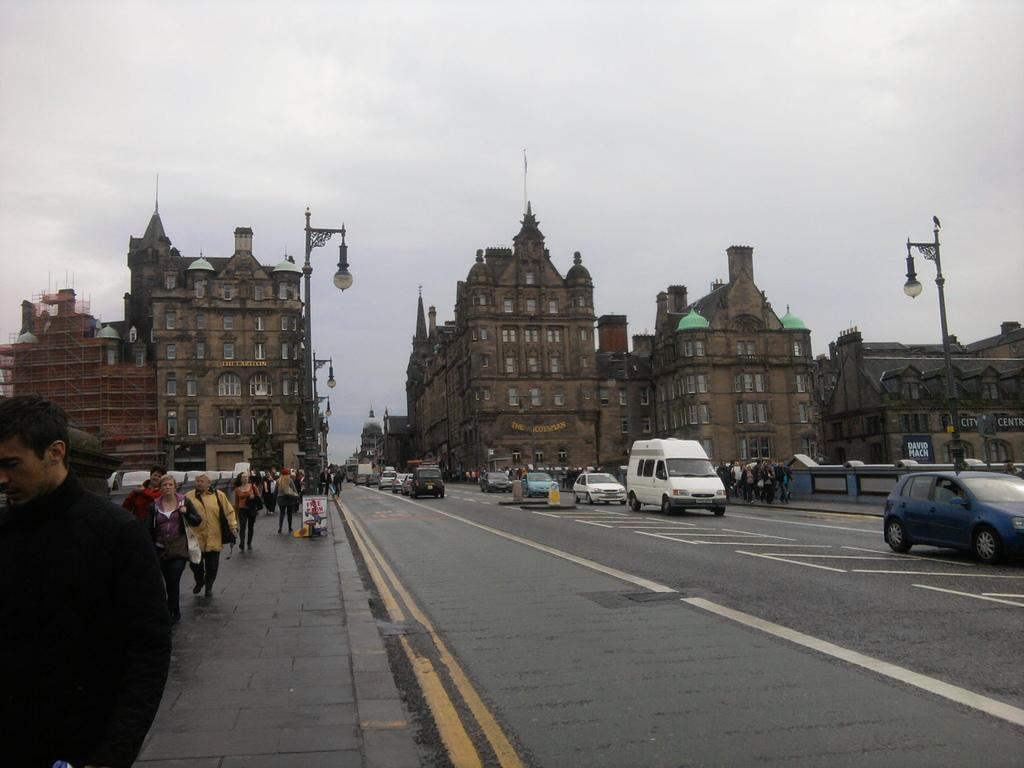What are the people in the image doing? The people in the image are walking. What else can be seen on the road in the image? There are vehicles on the road in the image. What type of infrastructure is present in the image? There are lights on poles in the image. What can be seen in the distance in the image? There are buildings in the background of the image, and the sky is visible in the background as well. What type of flight can be seen in the image? There is no flight visible in the image; it only shows people walking, vehicles, lights, buildings, and the sky. 